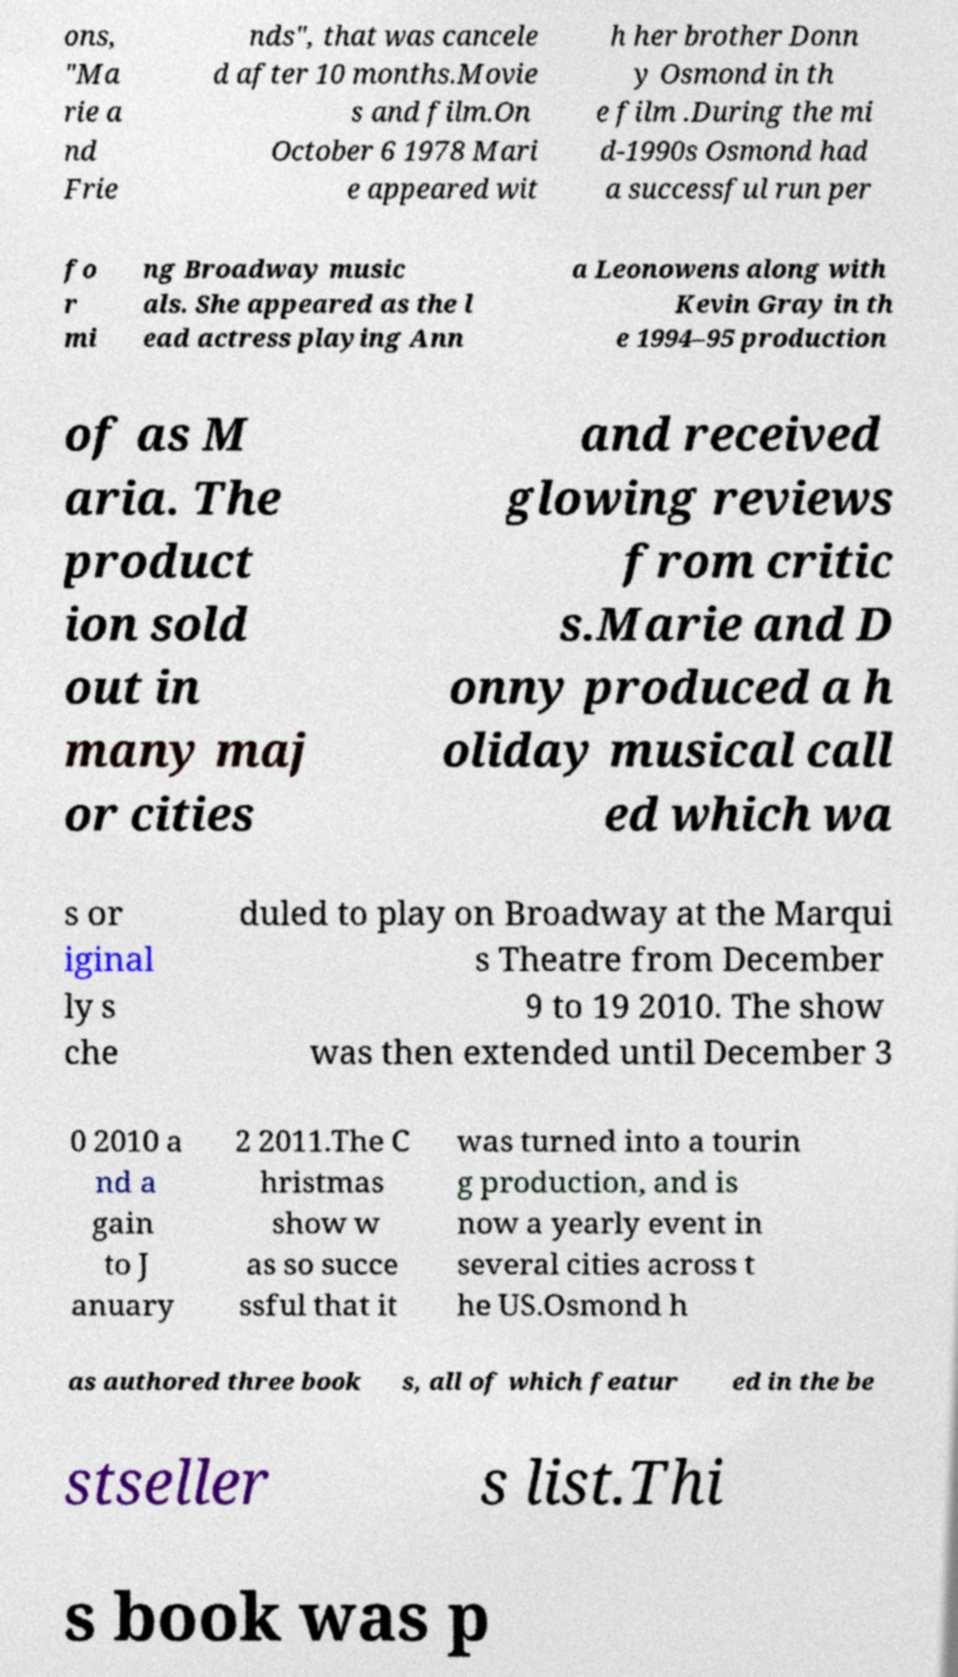What messages or text are displayed in this image? I need them in a readable, typed format. ons, "Ma rie a nd Frie nds", that was cancele d after 10 months.Movie s and film.On October 6 1978 Mari e appeared wit h her brother Donn y Osmond in th e film .During the mi d-1990s Osmond had a successful run per fo r mi ng Broadway music als. She appeared as the l ead actress playing Ann a Leonowens along with Kevin Gray in th e 1994–95 production of as M aria. The product ion sold out in many maj or cities and received glowing reviews from critic s.Marie and D onny produced a h oliday musical call ed which wa s or iginal ly s che duled to play on Broadway at the Marqui s Theatre from December 9 to 19 2010. The show was then extended until December 3 0 2010 a nd a gain to J anuary 2 2011.The C hristmas show w as so succe ssful that it was turned into a tourin g production, and is now a yearly event in several cities across t he US.Osmond h as authored three book s, all of which featur ed in the be stseller s list.Thi s book was p 